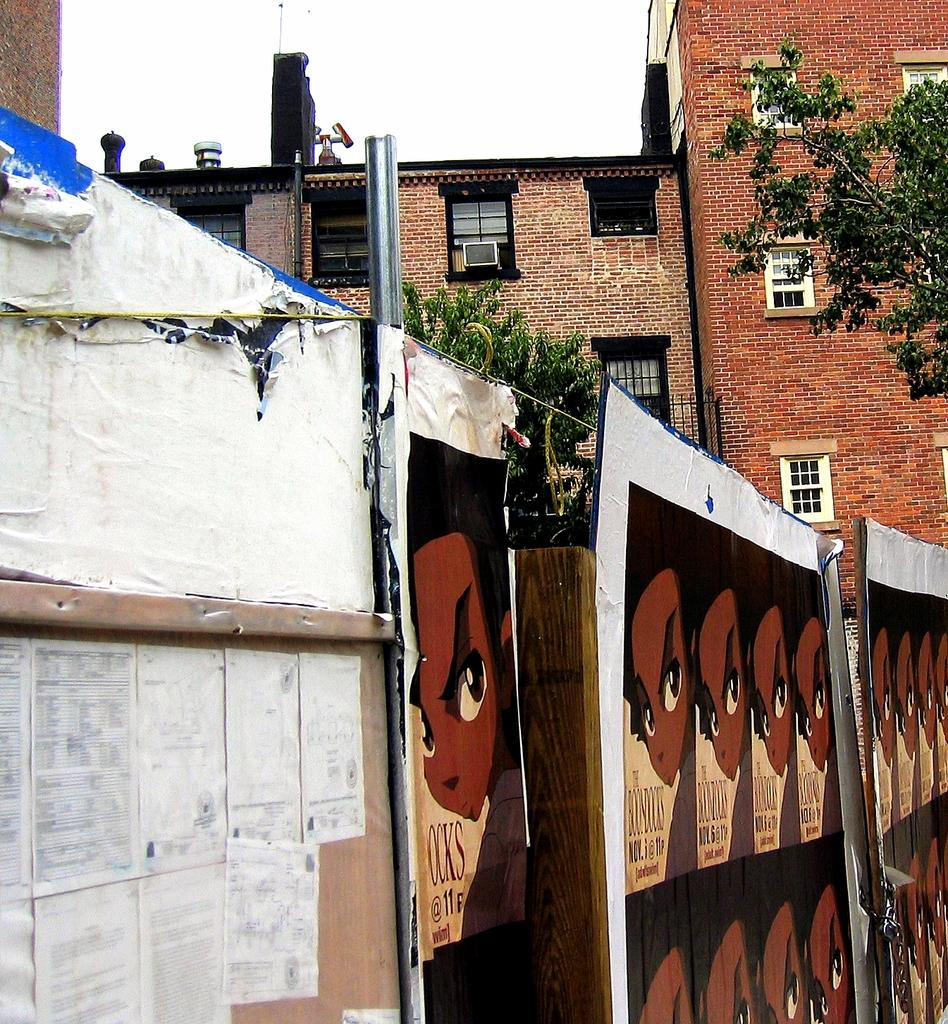What is present in the image that separates or encloses an area? There is a fence in the image. What is attached to the fence in the image? Papers and posters are attached to the fence in the image. What can be seen in the distance in the image? There is a building and trees in the background of the image. Where is the coat hanging in the image? There is no coat present in the image. What type of jelly can be seen on the fence in the image? There is no jelly present on the fence in the image. 